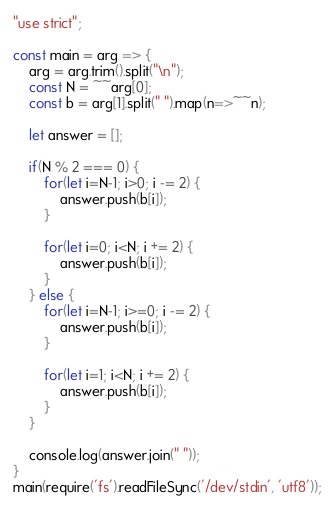<code> <loc_0><loc_0><loc_500><loc_500><_JavaScript_>
"use strict";
    
const main = arg => {
    arg = arg.trim().split("\n");
    const N = ~~arg[0];
    const b = arg[1].split(" ").map(n=>~~n);
    
    let answer = [];
    
    if(N % 2 === 0) {
        for(let i=N-1; i>0; i -= 2) {
            answer.push(b[i]);
        }
        
        for(let i=0; i<N; i += 2) {
            answer.push(b[i]);
        }
    } else {
        for(let i=N-1; i>=0; i -= 2) {
            answer.push(b[i]);
        }
        
        for(let i=1; i<N; i += 2) {
            answer.push(b[i]);
        }
    }
    
    console.log(answer.join(" "));
}
main(require('fs').readFileSync('/dev/stdin', 'utf8'));</code> 